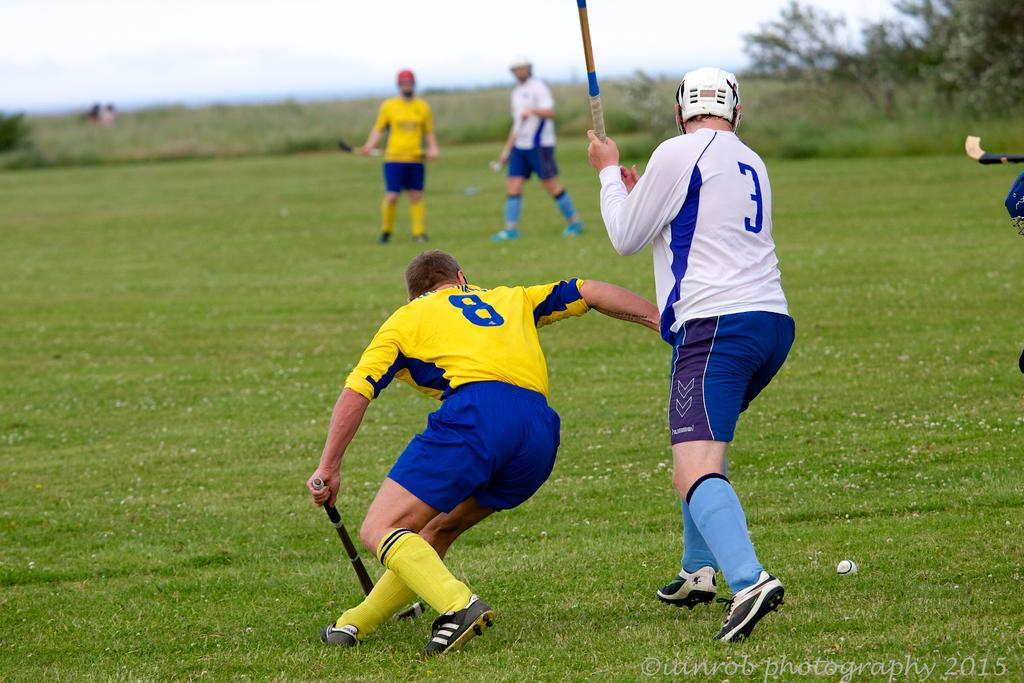<image>
Write a terse but informative summary of the picture. field hockey players with numbers 8 and 3 look for the ball 